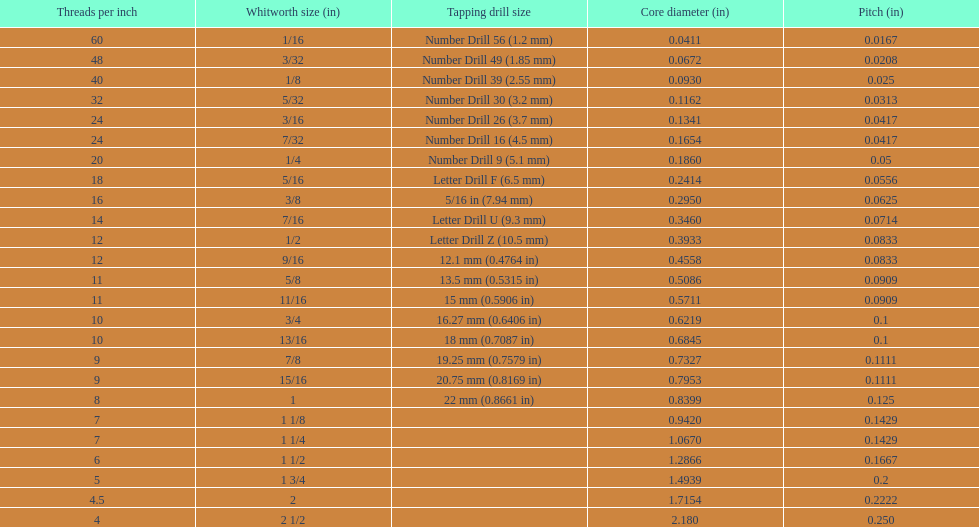What is the top amount of threads per inch? 60. 